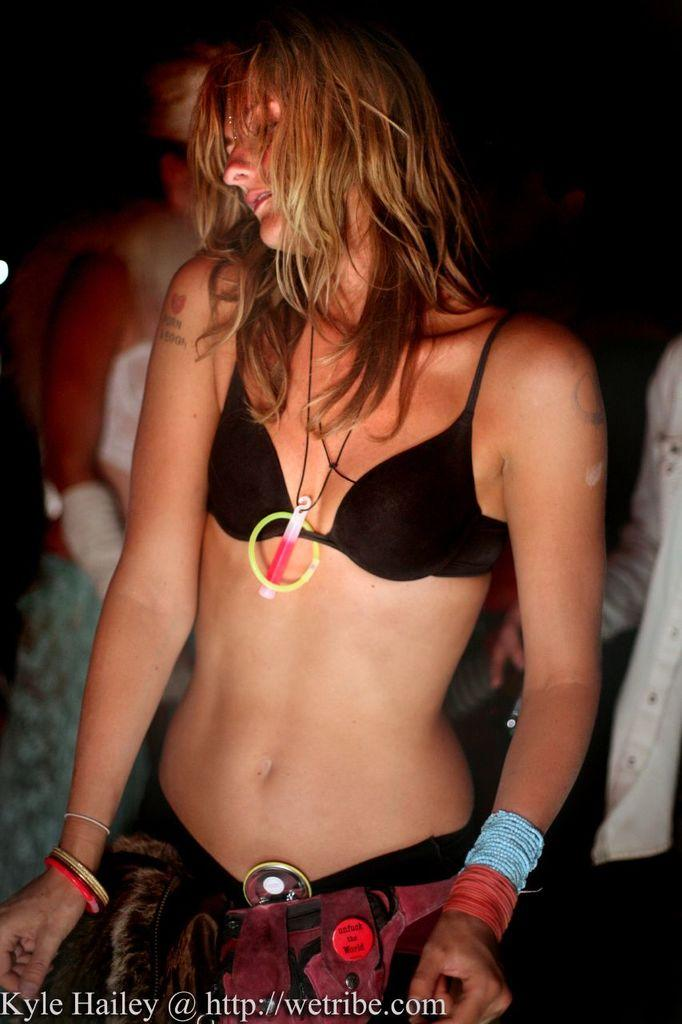Who is the main subject in the image? There is a woman in the middle of the image. What can be observed about the background of the image? The background of the image is dark. How many people are present in the image? There are two persons in the image. What is written at the bottom of the image? There is text written at the bottom of the image. What songs are being sung by the woman in the image? There is no indication in the image that the woman is singing any songs, so it cannot be determined from the picture. 